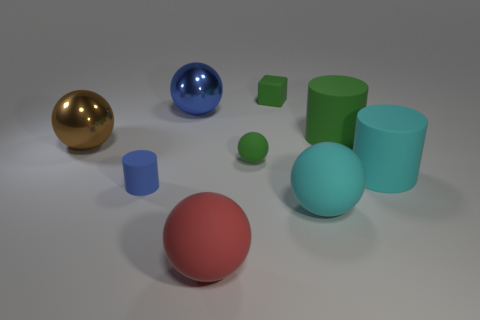How many cylinders are small purple rubber objects or red matte objects?
Provide a short and direct response. 0. What size is the rubber thing to the left of the blue object that is behind the tiny green thing in front of the green block?
Provide a short and direct response. Small. What color is the small object that is in front of the small green cube and right of the red matte thing?
Provide a short and direct response. Green. Does the brown metal ball have the same size as the matte object that is on the left side of the red thing?
Your response must be concise. No. Are there any other things that have the same shape as the large brown metallic thing?
Offer a very short reply. Yes. What is the color of the other big metal object that is the same shape as the large brown metal thing?
Keep it short and to the point. Blue. Is the size of the cyan sphere the same as the blue metal object?
Your response must be concise. Yes. What number of other things are the same size as the green rubber ball?
Provide a succinct answer. 2. What number of objects are either cyan matte things that are in front of the large cyan rubber cylinder or green rubber things that are on the left side of the large cyan matte sphere?
Keep it short and to the point. 3. There is a green rubber thing that is the same size as the green cube; what shape is it?
Offer a terse response. Sphere. 